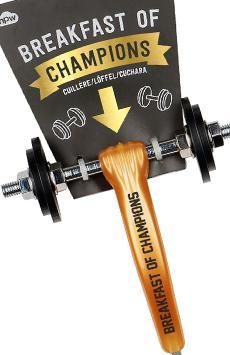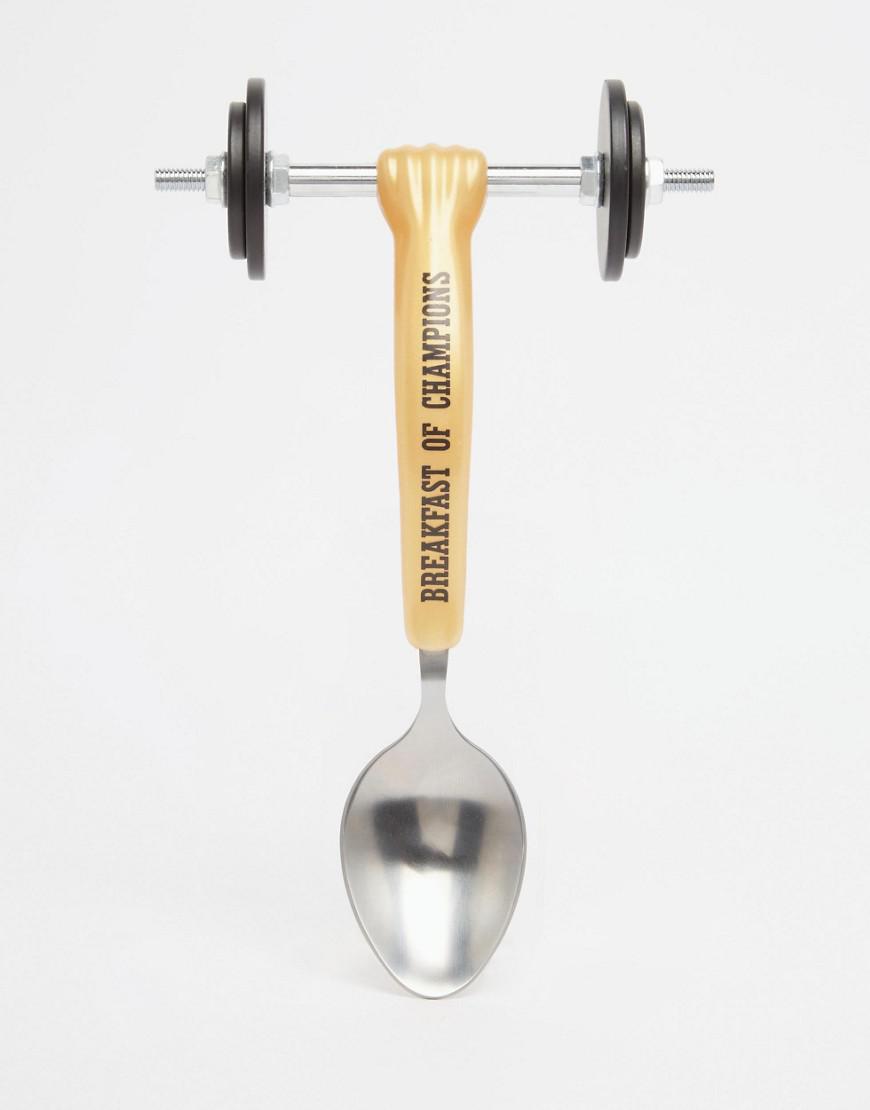The first image is the image on the left, the second image is the image on the right. Assess this claim about the two images: "The spoon is turned toward the bottom left in one of the images.". Correct or not? Answer yes or no. No. 